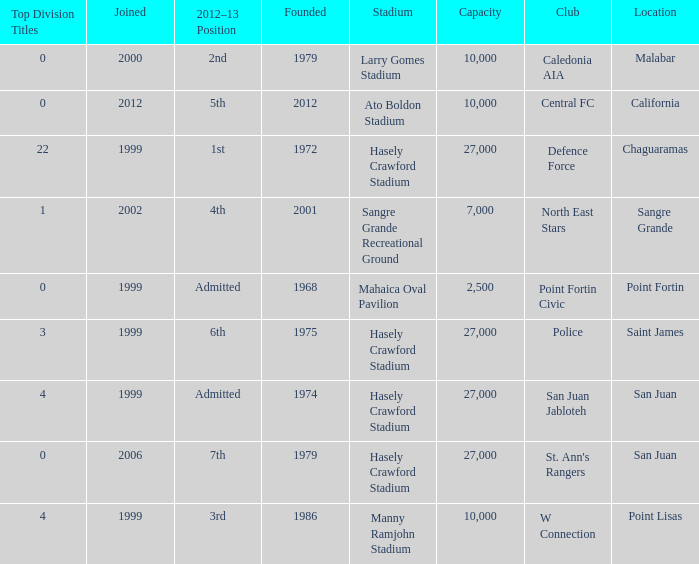Parse the full table. {'header': ['Top Division Titles', 'Joined', '2012–13 Position', 'Founded', 'Stadium', 'Capacity', 'Club', 'Location'], 'rows': [['0', '2000', '2nd', '1979', 'Larry Gomes Stadium', '10,000', 'Caledonia AIA', 'Malabar'], ['0', '2012', '5th', '2012', 'Ato Boldon Stadium', '10,000', 'Central FC', 'California'], ['22', '1999', '1st', '1972', 'Hasely Crawford Stadium', '27,000', 'Defence Force', 'Chaguaramas'], ['1', '2002', '4th', '2001', 'Sangre Grande Recreational Ground', '7,000', 'North East Stars', 'Sangre Grande'], ['0', '1999', 'Admitted', '1968', 'Mahaica Oval Pavilion', '2,500', 'Point Fortin Civic', 'Point Fortin'], ['3', '1999', '6th', '1975', 'Hasely Crawford Stadium', '27,000', 'Police', 'Saint James'], ['4', '1999', 'Admitted', '1974', 'Hasely Crawford Stadium', '27,000', 'San Juan Jabloteh', 'San Juan'], ['0', '2006', '7th', '1979', 'Hasely Crawford Stadium', '27,000', "St. Ann's Rangers", 'San Juan'], ['4', '1999', '3rd', '1986', 'Manny Ramjohn Stadium', '10,000', 'W Connection', 'Point Lisas']]} What was the total number of Top Division Titles where the year founded was prior to 1975 and the location was in Chaguaramas? 22.0. 